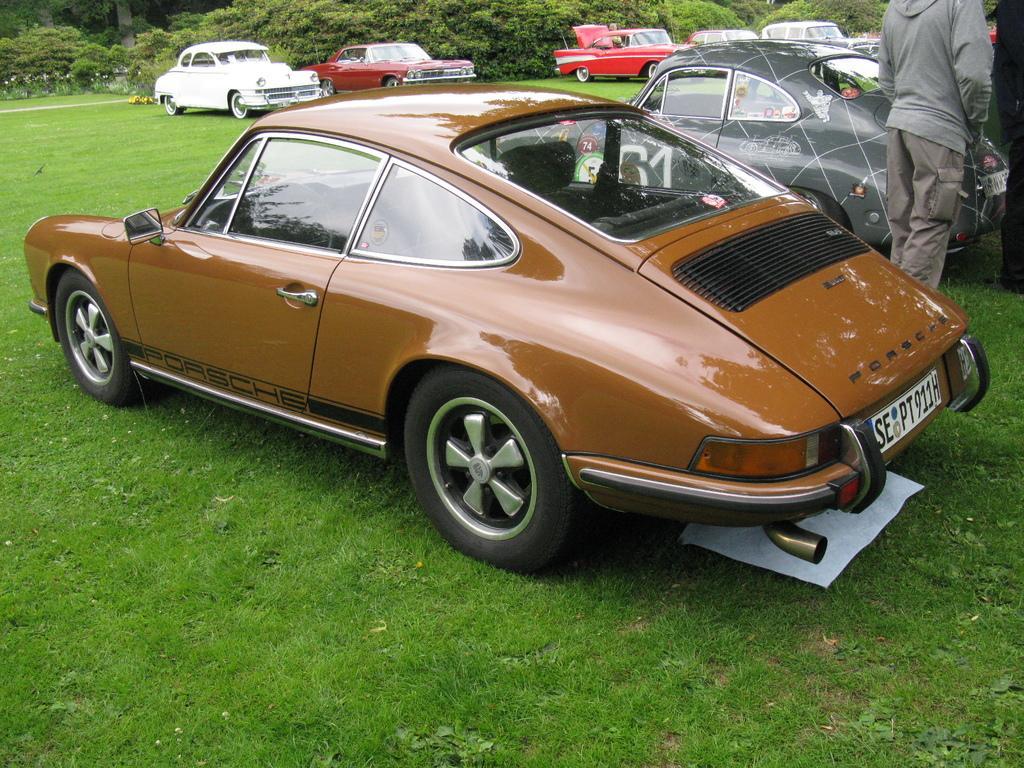Describe this image in one or two sentences. This picture is clicked outside. In the center we can see the group of cars parked on the ground. On the right we can see the two persons standing on the ground and we can see the green grass, plants, trees and some other objects. 